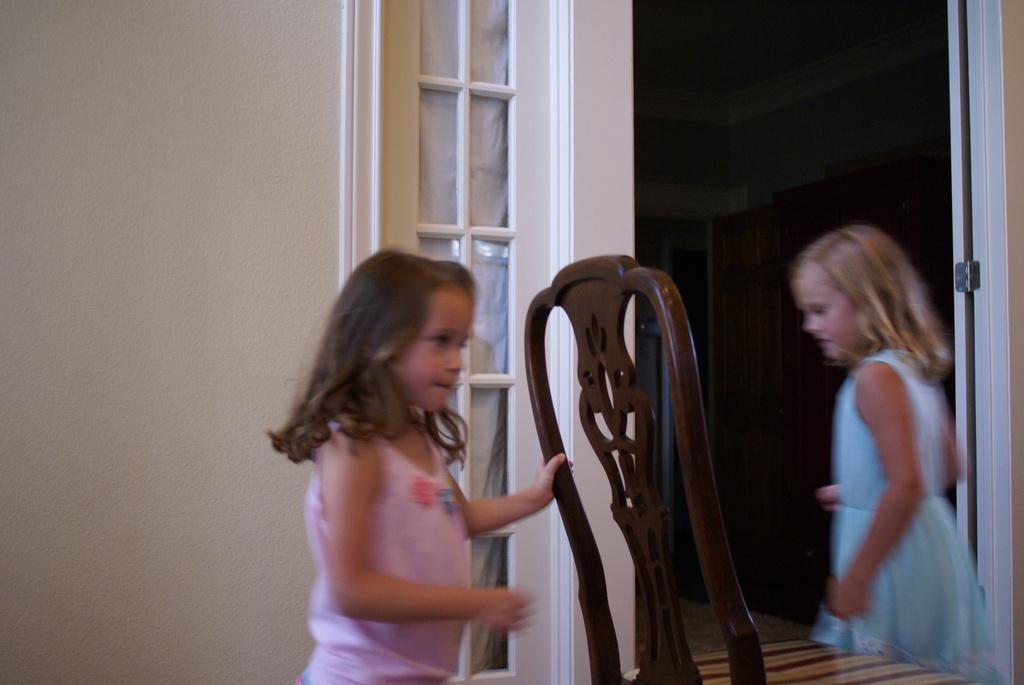In one or two sentences, can you explain what this image depicts? On the left side, there is a girl in a pink color dress, holding a wooden chair. On the right side, there is a girl in a blue color dress. In the background, there is a white wall. 